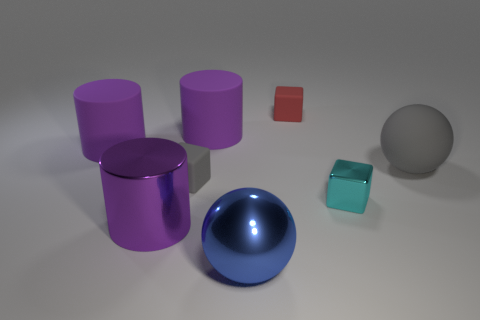Subtract all purple rubber cylinders. How many cylinders are left? 1 Add 1 tiny purple matte objects. How many objects exist? 9 Subtract all cyan blocks. How many blocks are left? 2 Subtract all blocks. How many objects are left? 5 Subtract 2 cubes. How many cubes are left? 1 Subtract 0 brown balls. How many objects are left? 8 Subtract all blue cylinders. Subtract all yellow cubes. How many cylinders are left? 3 Subtract all cyan balls. How many green cubes are left? 0 Subtract all small matte cubes. Subtract all tiny gray matte objects. How many objects are left? 5 Add 7 gray balls. How many gray balls are left? 8 